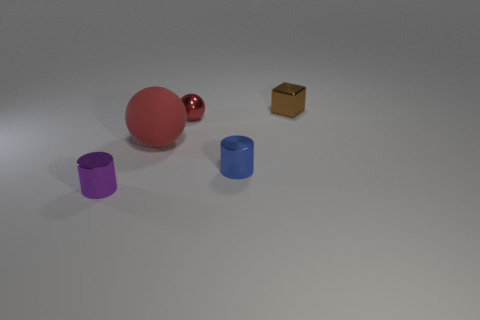Are there any other things that are the same material as the big red sphere?
Make the answer very short. No. How many spheres are tiny blue things or small metal objects?
Make the answer very short. 1. There is another ball that is the same color as the big rubber ball; what material is it?
Your response must be concise. Metal. Are there fewer brown objects left of the small red shiny sphere than big red rubber balls that are in front of the purple object?
Provide a succinct answer. No. How many things are either metal things to the left of the tiny brown shiny block or balls?
Provide a succinct answer. 4. The tiny object that is to the right of the cylinder that is right of the tiny red shiny ball is what shape?
Provide a succinct answer. Cube. Are there any other purple cylinders of the same size as the purple shiny cylinder?
Provide a short and direct response. No. Is the number of purple metal things greater than the number of red things?
Make the answer very short. No. There is a shiny cylinder that is to the left of the big red object; does it have the same size as the shiny cylinder right of the big rubber sphere?
Offer a terse response. Yes. How many things are both left of the small blue object and in front of the matte object?
Offer a terse response. 1. 